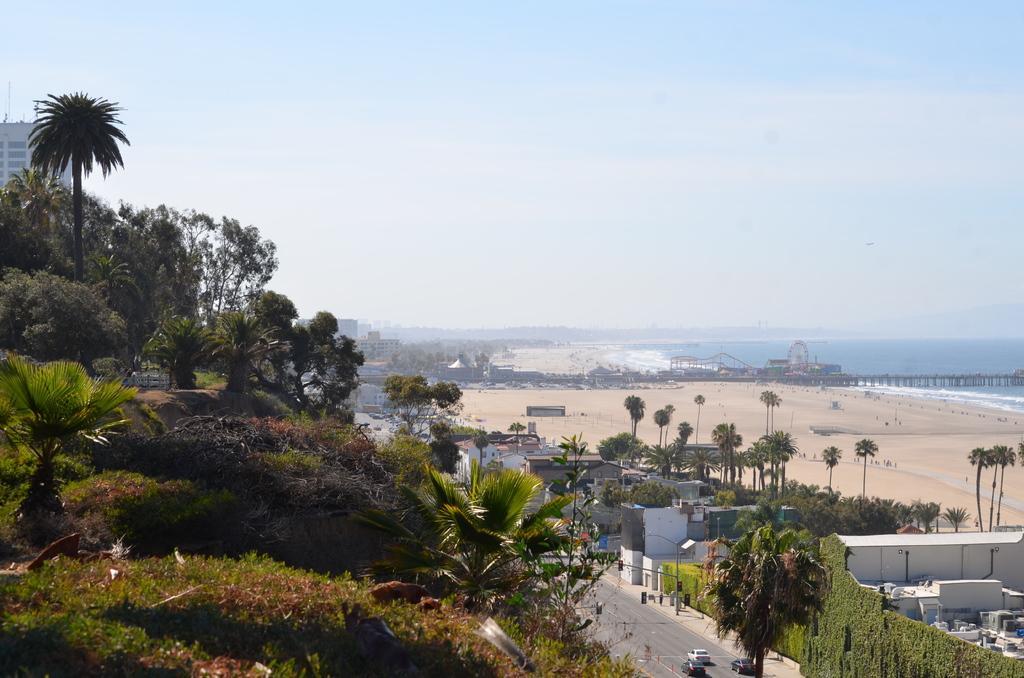Can you describe this image briefly? In this picture we can see trees, plants, vehicles on the road, buildings, pole and ground. In the background of the image we can see bridgewater, Ferris wheel, sky and objects. 